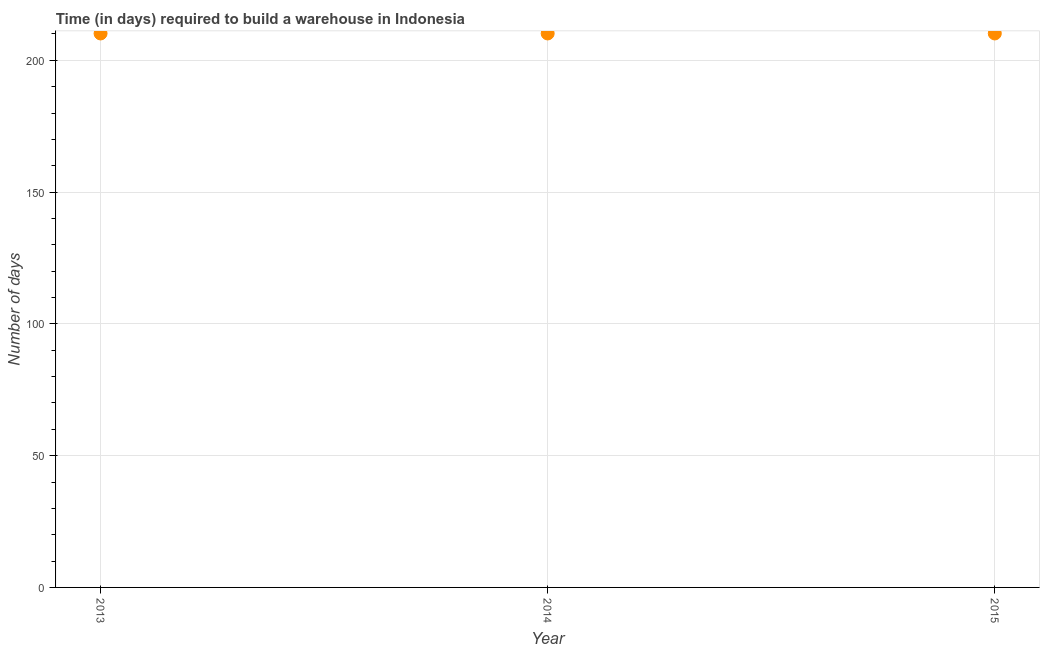What is the time required to build a warehouse in 2013?
Your answer should be very brief. 210.2. Across all years, what is the maximum time required to build a warehouse?
Your answer should be compact. 210.2. Across all years, what is the minimum time required to build a warehouse?
Your answer should be compact. 210.2. In which year was the time required to build a warehouse minimum?
Your answer should be compact. 2013. What is the sum of the time required to build a warehouse?
Provide a succinct answer. 630.6. What is the difference between the time required to build a warehouse in 2013 and 2014?
Your answer should be compact. 0. What is the average time required to build a warehouse per year?
Make the answer very short. 210.2. What is the median time required to build a warehouse?
Make the answer very short. 210.2. Is the time required to build a warehouse in 2013 less than that in 2015?
Make the answer very short. No. Is the sum of the time required to build a warehouse in 2013 and 2015 greater than the maximum time required to build a warehouse across all years?
Your answer should be very brief. Yes. In how many years, is the time required to build a warehouse greater than the average time required to build a warehouse taken over all years?
Ensure brevity in your answer.  3. Are the values on the major ticks of Y-axis written in scientific E-notation?
Offer a very short reply. No. Does the graph contain grids?
Give a very brief answer. Yes. What is the title of the graph?
Offer a terse response. Time (in days) required to build a warehouse in Indonesia. What is the label or title of the Y-axis?
Make the answer very short. Number of days. What is the Number of days in 2013?
Your response must be concise. 210.2. What is the Number of days in 2014?
Your answer should be compact. 210.2. What is the Number of days in 2015?
Keep it short and to the point. 210.2. What is the difference between the Number of days in 2013 and 2015?
Your answer should be compact. 0. What is the ratio of the Number of days in 2013 to that in 2014?
Your answer should be very brief. 1. What is the ratio of the Number of days in 2014 to that in 2015?
Your answer should be compact. 1. 